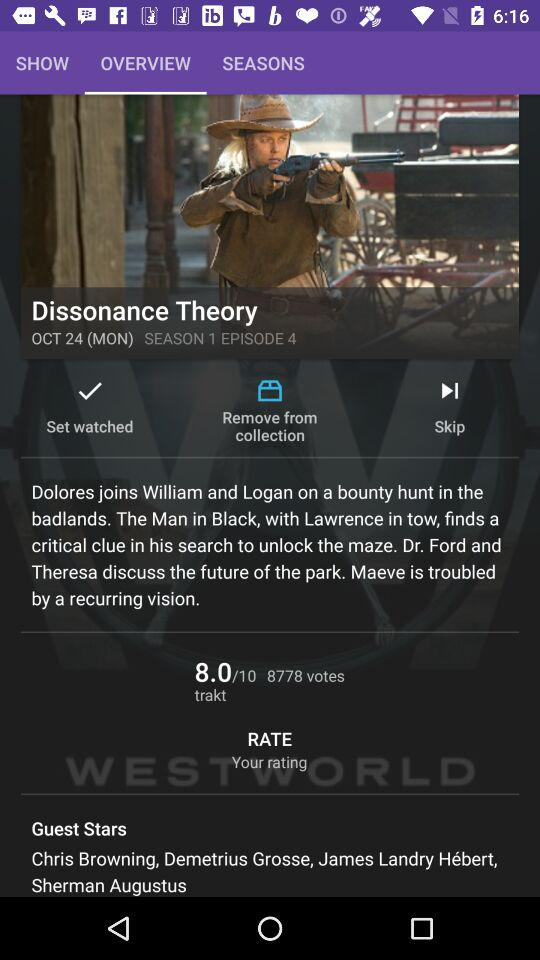Which season is this? This is season 1. 